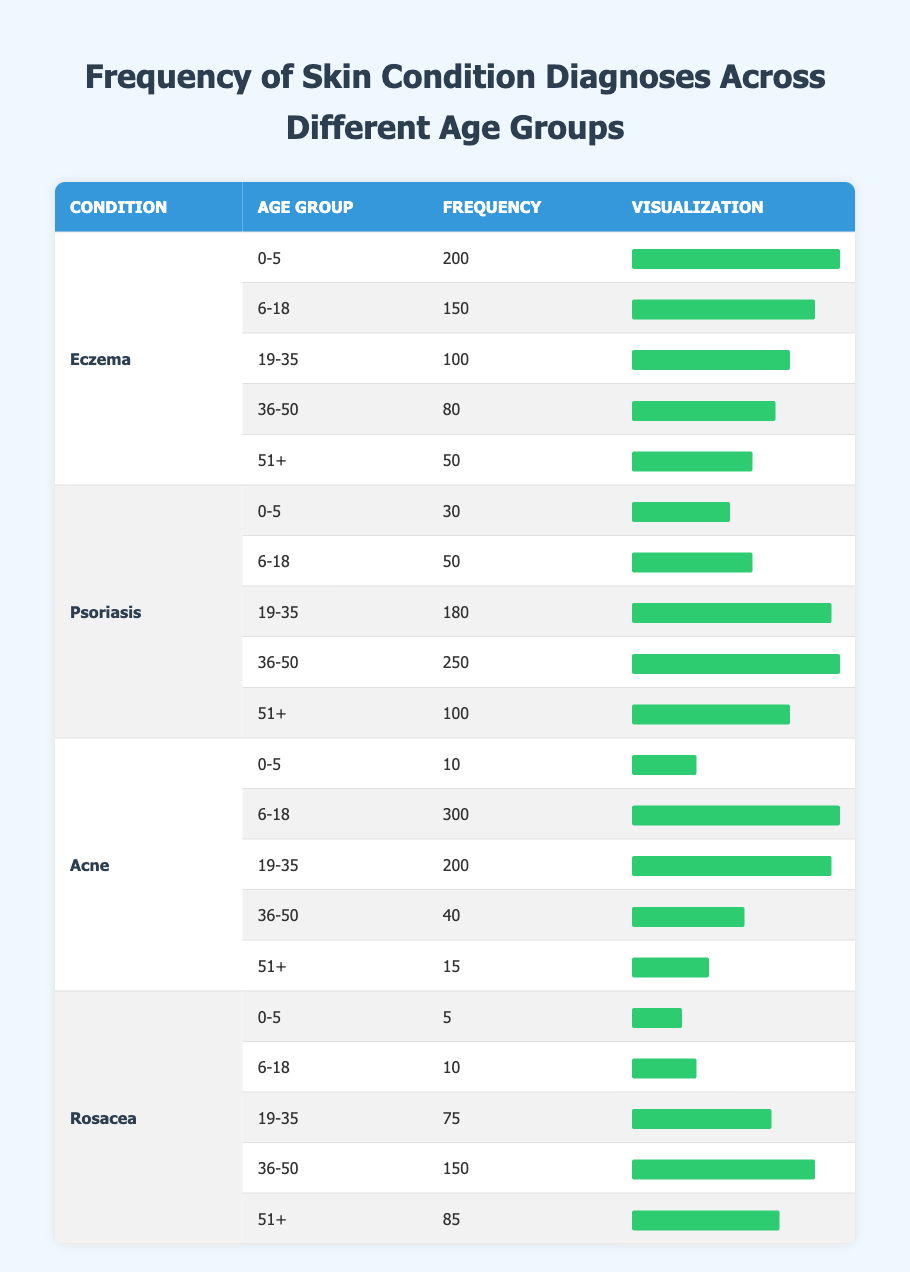What is the frequency of Eczema diagnoses in the 0-5 age group? The table lists the frequency of Eczema diagnoses specifically for the 0-5 age group, which is indicated as 200.
Answer: 200 What is the frequency of Acne diagnoses in the 36-50 age group? According to the table, the frequency of Acne diagnoses for the 36-50 age group is shown as 40.
Answer: 40 Does the frequency of Psoriasis diagnoses increase with age? By examining the frequency across age groups for Psoriasis, it can be seen that the frequencies are: 30, 50, 180, 250, and 100 for the respective age groups. The values show an increase from ages 0-5 to 36-50, but a decrease in the 51+ age group. Thus, it does not consistently increase with age.
Answer: No What is the total frequency of Rosacea diagnoses across all age groups? The individual frequencies for Rosacea are 5, 10, 75, 150, and 85 for the age groups 0-5, 6-18, 19-35, 36-50, and 51+, respectively. Summing these gives: 5 + 10 + 75 + 150 + 85 = 325.
Answer: 325 What percentage of the frequency in the 6-18 age group is accounted for by Acne cases? The frequency of Acne for the 6-18 age group is 300, and the total frequency of all conditions for that age group is 300 (Acne) + 150 (Eczema) + 50 (Psoriasis) + 10 (Rosacea) = 510. The percentage is then calculated as (300/510) * 100 ≈ 58.82%.
Answer: Approximately 58.82% What condition has the highest total frequency across all age groups? To determine which condition has the highest total frequency, I'll sum the frequencies for Eczema (200 + 150 + 100 + 80 + 50), Psoriasis (30 + 50 + 180 + 250 + 100), Acne (10 + 300 + 200 + 40 + 15), and Rosacea (5 + 10 + 75 + 150 + 85). The totals are: Eczema = 580, Psoriasis = 610, Acne = 565, Rosacea = 325. The highest total frequency is for Psoriasis with 610.
Answer: Psoriasis Is the frequency of skin conditions higher in the younger age groups (0-5 and 6-18) compared to the older age groups (36-50 and 51+)? The total frequencies for the younger age groups are: Eczema: 200 + 150, Psoriasis: 30 + 50, Acne: 10 + 300, and Rosacea: 5 + 10. Summing gives 200 + 150 + 30 + 50 + 10 + 300 + 5 + 10 = 755. The older age groups have frequencies: Eczema: 80 + 50, Psoriasis: 250 + 100, Acne: 40 + 15, and Rosacea: 150 + 85. This sums to 80 + 50 + 250 + 100 + 40 + 15 + 150 + 85 = 670. Thus, the younger groups have a higher total frequency of 755 compared to 670 for the older groups.
Answer: Yes What is the average frequency of diagnoses for the 51+ age group across all conditions? The frequencies for the 51+ age group are: Eczema: 50, Psoriasis: 100, Acne: 15, and Rosacea: 85. The average is calculated by summing these values (50 + 100 + 15 + 85) = 250 and dividing by the number of conditions (4): 250/4 = 62.5.
Answer: 62.5 